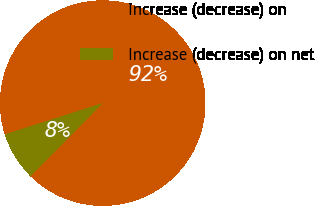<chart> <loc_0><loc_0><loc_500><loc_500><pie_chart><fcel>Increase (decrease) on<fcel>Increase (decrease) on net<nl><fcel>92.31%<fcel>7.69%<nl></chart> 